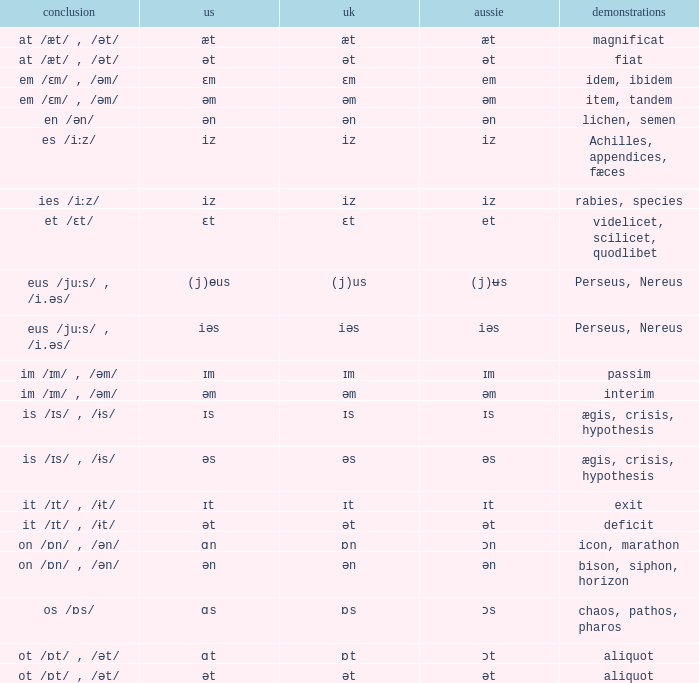Which Australian has British of ɒs? Ɔs. 